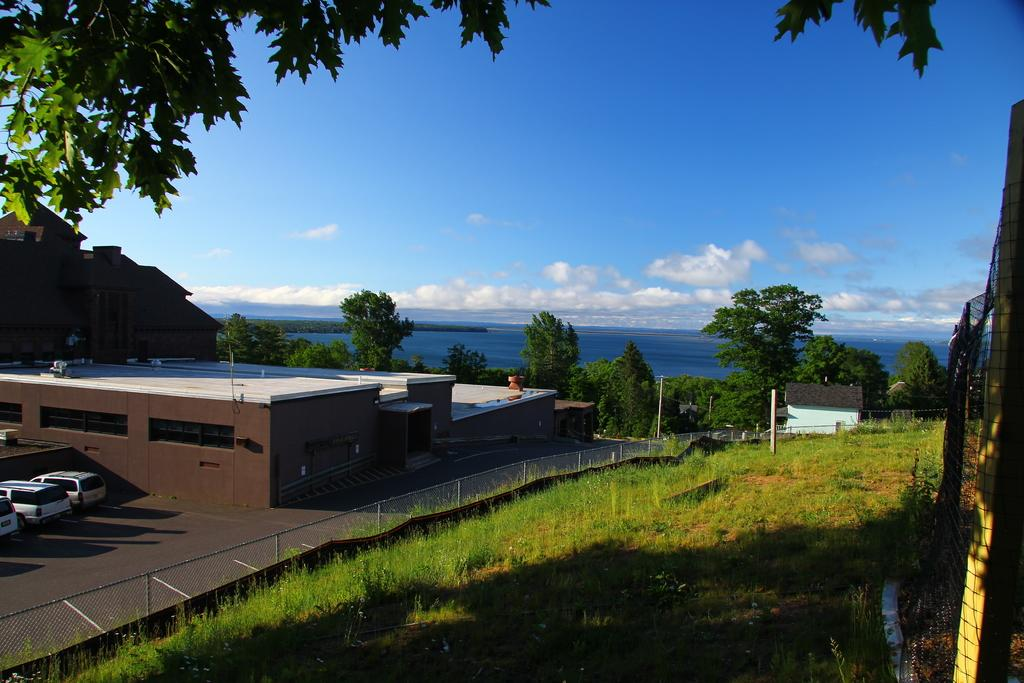What type of vegetation is present on the ground in the front of the image? There is grass on the ground in the front of the image. What can be seen in the center of the image? There is a fence in the center of the image. What is visible in the background of the image? Buildings, cars, trees, and water are visible in the background of the image. What is the condition of the sky in the image? The sky is cloudy in the image. Where is the faucet located in the image? There is no faucet present in the image. What type of cream can be seen on the trees in the background? There is no cream visible on the trees in the background; they are simply trees. 